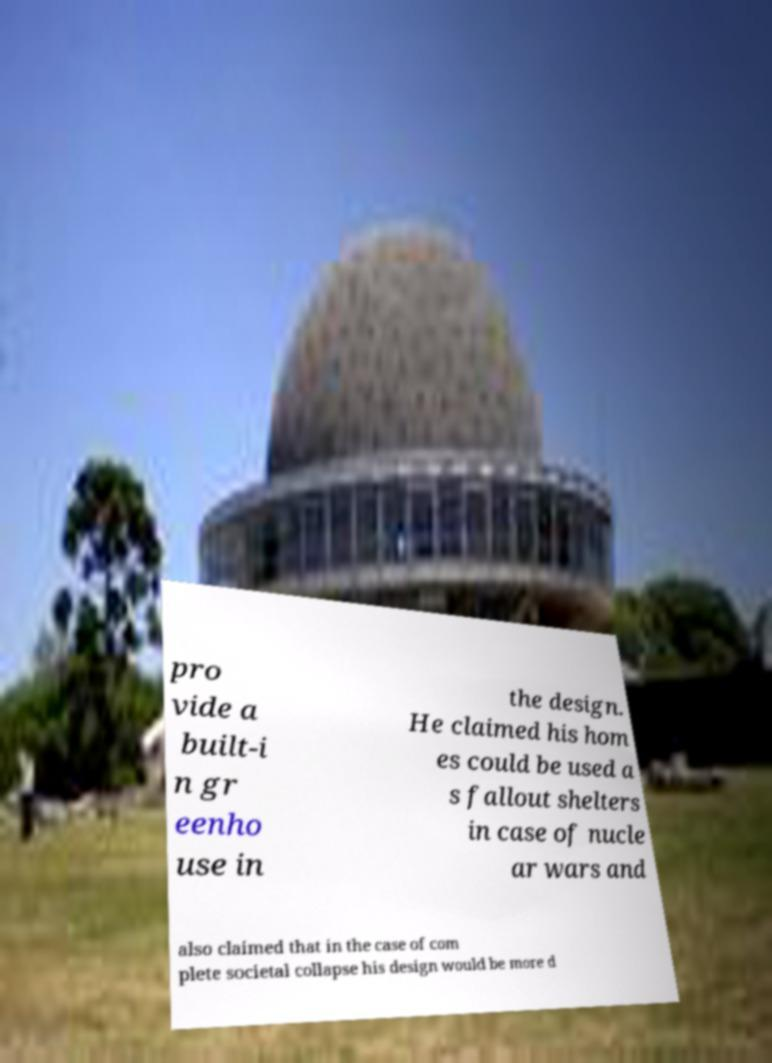What messages or text are displayed in this image? I need them in a readable, typed format. pro vide a built-i n gr eenho use in the design. He claimed his hom es could be used a s fallout shelters in case of nucle ar wars and also claimed that in the case of com plete societal collapse his design would be more d 